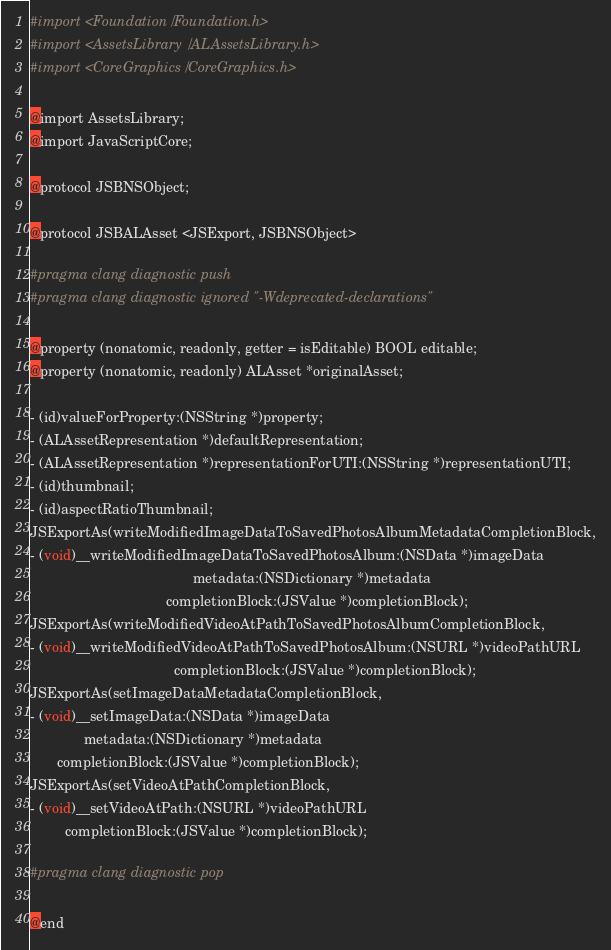<code> <loc_0><loc_0><loc_500><loc_500><_C_>#import <Foundation/Foundation.h>
#import <AssetsLibrary/ALAssetsLibrary.h>
#import <CoreGraphics/CoreGraphics.h>

@import AssetsLibrary;
@import JavaScriptCore;

@protocol JSBNSObject;

@protocol JSBALAsset <JSExport, JSBNSObject>

#pragma clang diagnostic push
#pragma clang diagnostic ignored "-Wdeprecated-declarations"

@property (nonatomic, readonly, getter = isEditable) BOOL editable;
@property (nonatomic, readonly) ALAsset *originalAsset;

- (id)valueForProperty:(NSString *)property;
- (ALAssetRepresentation *)defaultRepresentation;
- (ALAssetRepresentation *)representationForUTI:(NSString *)representationUTI;
- (id)thumbnail;
- (id)aspectRatioThumbnail;
JSExportAs(writeModifiedImageDataToSavedPhotosAlbumMetadataCompletionBlock,
- (void)__writeModifiedImageDataToSavedPhotosAlbum:(NSData *)imageData
                                          metadata:(NSDictionary *)metadata
                                   completionBlock:(JSValue *)completionBlock);
JSExportAs(writeModifiedVideoAtPathToSavedPhotosAlbumCompletionBlock,
- (void)__writeModifiedVideoAtPathToSavedPhotosAlbum:(NSURL *)videoPathURL
                                     completionBlock:(JSValue *)completionBlock);
JSExportAs(setImageDataMetadataCompletionBlock,
- (void)__setImageData:(NSData *)imageData
              metadata:(NSDictionary *)metadata
       completionBlock:(JSValue *)completionBlock);
JSExportAs(setVideoAtPathCompletionBlock,
- (void)__setVideoAtPath:(NSURL *)videoPathURL
         completionBlock:(JSValue *)completionBlock);

#pragma clang diagnostic pop

@end
</code> 